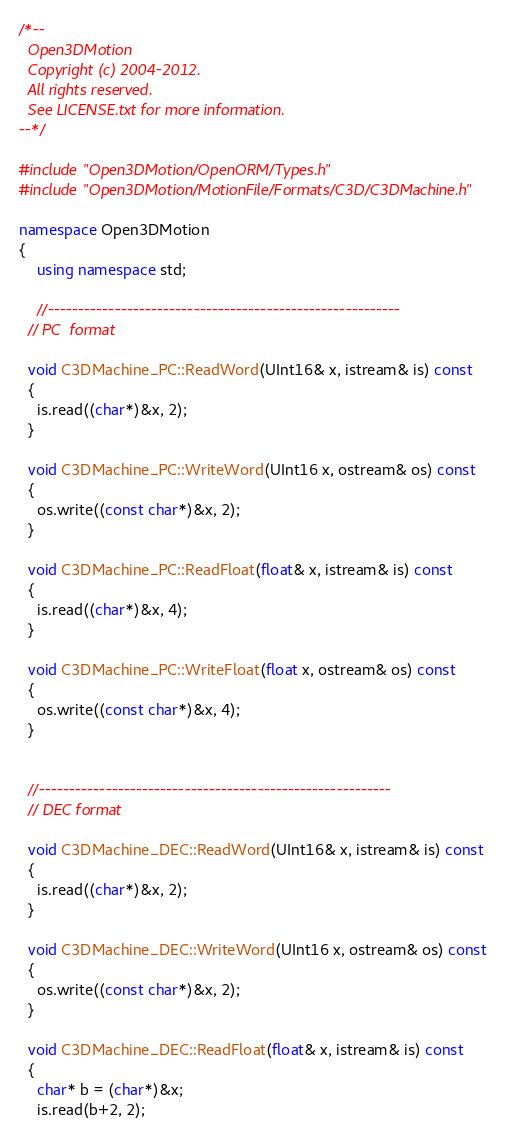<code> <loc_0><loc_0><loc_500><loc_500><_C++_>/*--
  Open3DMotion 
  Copyright (c) 2004-2012.
  All rights reserved.
  See LICENSE.txt for more information.
--*/

#include "Open3DMotion/OpenORM/Types.h"
#include "Open3DMotion/MotionFile/Formats/C3D/C3DMachine.h"

namespace Open3DMotion
{
	using namespace std;

	//----------------------------------------------------------
  // PC  format
  
  void C3DMachine_PC::ReadWord(UInt16& x, istream& is) const
  {
    is.read((char*)&x, 2);
  }

  void C3DMachine_PC::WriteWord(UInt16 x, ostream& os) const
  {
    os.write((const char*)&x, 2);
  }

  void C3DMachine_PC::ReadFloat(float& x, istream& is) const
  {
    is.read((char*)&x, 4);
  }
  
  void C3DMachine_PC::WriteFloat(float x, ostream& os) const
  {
    os.write((const char*)&x, 4);
  }


  //----------------------------------------------------------
  // DEC format
  
  void C3DMachine_DEC::ReadWord(UInt16& x, istream& is) const
  {
    is.read((char*)&x, 2);
  }

  void C3DMachine_DEC::WriteWord(UInt16 x, ostream& os) const
  {
    os.write((const char*)&x, 2);
  }

  void C3DMachine_DEC::ReadFloat(float& x, istream& is) const
  {
    char* b = (char*)&x;
    is.read(b+2, 2);</code> 